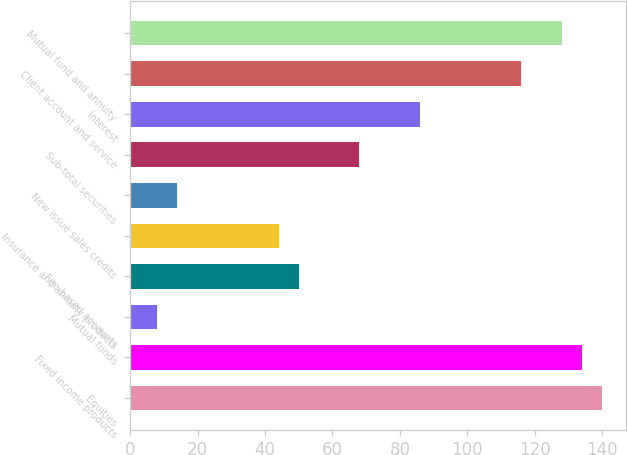<chart> <loc_0><loc_0><loc_500><loc_500><bar_chart><fcel>Equities<fcel>Fixed income products<fcel>Mutual funds<fcel>Fee-based accounts<fcel>Insurance and annuity products<fcel>New issue sales credits<fcel>Sub-total securities<fcel>Interest<fcel>Client account and service<fcel>Mutual fund and annuity<nl><fcel>140<fcel>134<fcel>8<fcel>50<fcel>44<fcel>14<fcel>68<fcel>86<fcel>116<fcel>128<nl></chart> 